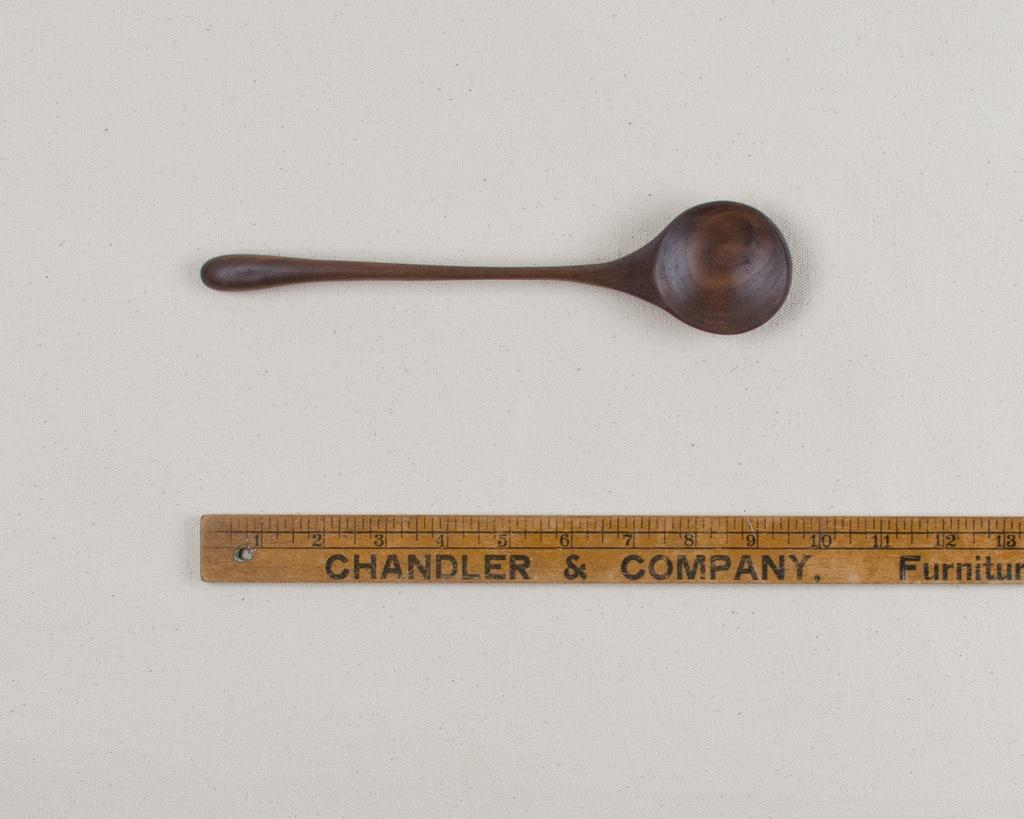<image>
Create a compact narrative representing the image presented. A 10 inch long round bowled dark colored wooden spoon next to a Chandler & Company ruler. 